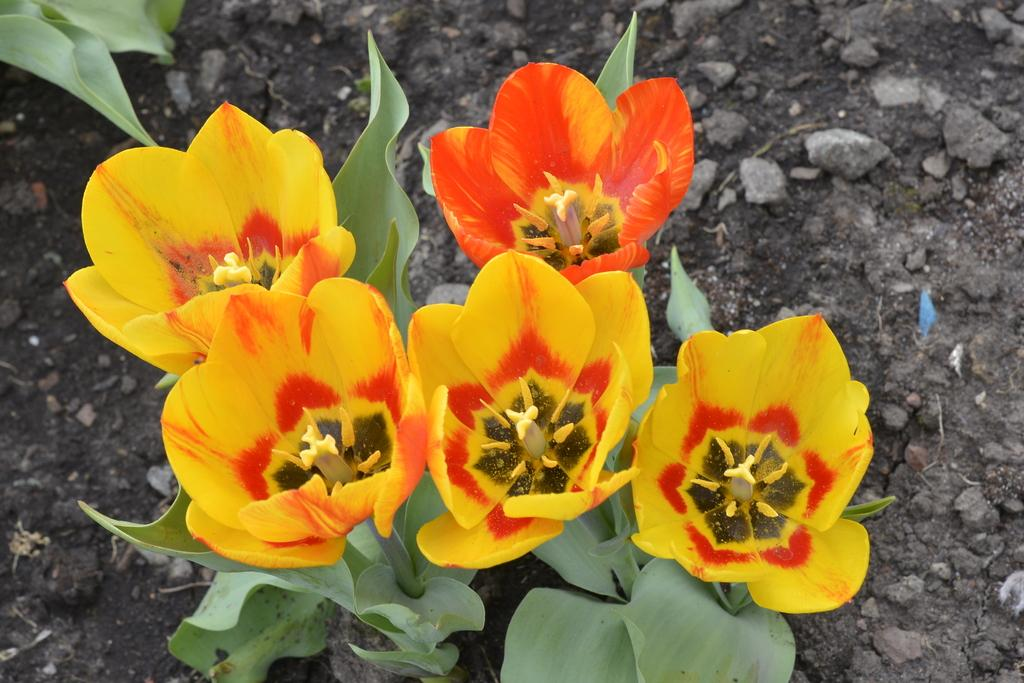What type of plants can be seen in the image? There are flower plants in the image. Where are the flower plants located? The flower plants are on the ground. What type of disease affects the flower plants in the image? There is no indication of any disease affecting the flower plants in the image. 